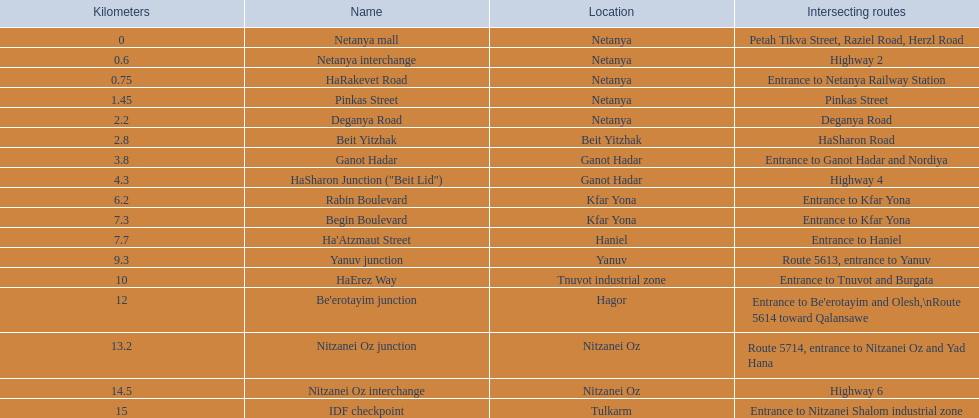What are the various segments? Netanya mall, Netanya interchange, HaRakevet Road, Pinkas Street, Deganya Road, Beit Yitzhak, Ganot Hadar, HaSharon Junction ("Beit Lid"), Rabin Boulevard, Begin Boulevard, Ha'Atzmaut Street, Yanuv junction, HaErez Way, Be'erotayim junction, Nitzanei Oz junction, Nitzanei Oz interchange, IDF checkpoint. What is the crossing path for rabin boulevard? Entrance to Kfar Yona. Which segment also includes an intersecting route for entry to kfar yona? Begin Boulevard. 